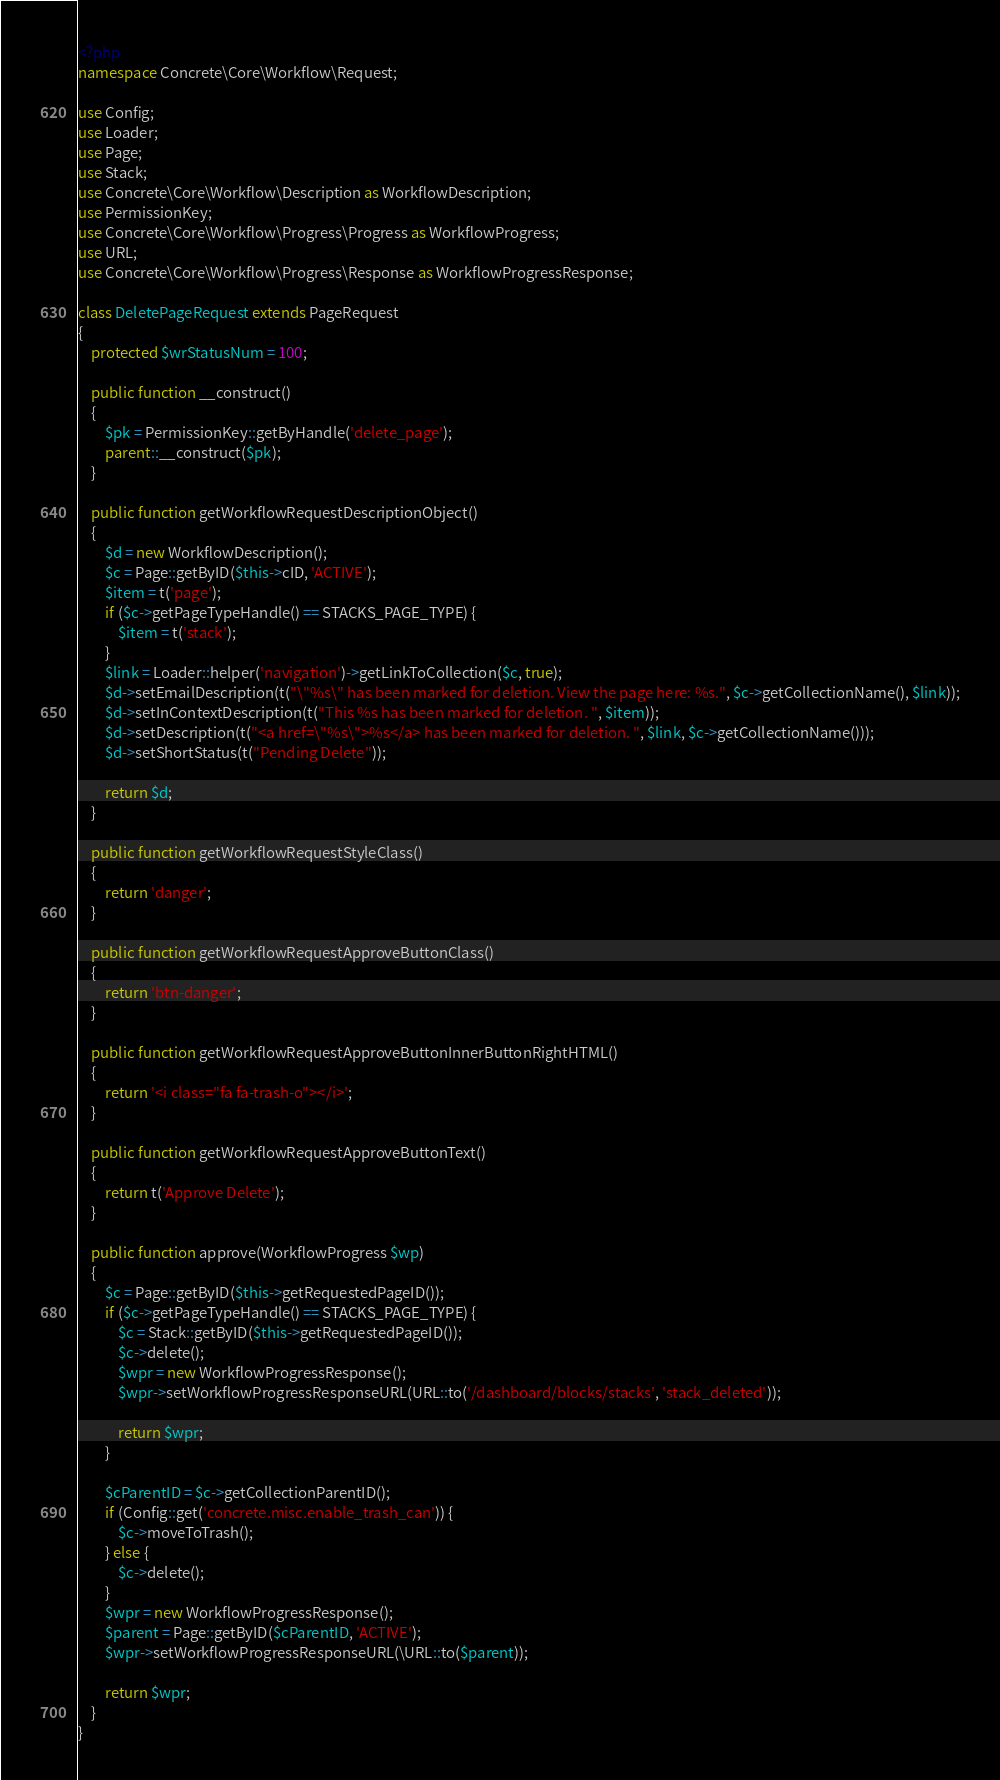<code> <loc_0><loc_0><loc_500><loc_500><_PHP_><?php
namespace Concrete\Core\Workflow\Request;

use Config;
use Loader;
use Page;
use Stack;
use Concrete\Core\Workflow\Description as WorkflowDescription;
use PermissionKey;
use Concrete\Core\Workflow\Progress\Progress as WorkflowProgress;
use URL;
use Concrete\Core\Workflow\Progress\Response as WorkflowProgressResponse;

class DeletePageRequest extends PageRequest
{
    protected $wrStatusNum = 100;

    public function __construct()
    {
        $pk = PermissionKey::getByHandle('delete_page');
        parent::__construct($pk);
    }

    public function getWorkflowRequestDescriptionObject()
    {
        $d = new WorkflowDescription();
        $c = Page::getByID($this->cID, 'ACTIVE');
        $item = t('page');
        if ($c->getPageTypeHandle() == STACKS_PAGE_TYPE) {
            $item = t('stack');
        }
        $link = Loader::helper('navigation')->getLinkToCollection($c, true);
        $d->setEmailDescription(t("\"%s\" has been marked for deletion. View the page here: %s.", $c->getCollectionName(), $link));
        $d->setInContextDescription(t("This %s has been marked for deletion. ", $item));
        $d->setDescription(t("<a href=\"%s\">%s</a> has been marked for deletion. ", $link, $c->getCollectionName()));
        $d->setShortStatus(t("Pending Delete"));

        return $d;
    }

    public function getWorkflowRequestStyleClass()
    {
        return 'danger';
    }

    public function getWorkflowRequestApproveButtonClass()
    {
        return 'btn-danger';
    }

    public function getWorkflowRequestApproveButtonInnerButtonRightHTML()
    {
        return '<i class="fa fa-trash-o"></i>';
    }

    public function getWorkflowRequestApproveButtonText()
    {
        return t('Approve Delete');
    }

    public function approve(WorkflowProgress $wp)
    {
        $c = Page::getByID($this->getRequestedPageID());
        if ($c->getPageTypeHandle() == STACKS_PAGE_TYPE) {
            $c = Stack::getByID($this->getRequestedPageID());
            $c->delete();
            $wpr = new WorkflowProgressResponse();
            $wpr->setWorkflowProgressResponseURL(URL::to('/dashboard/blocks/stacks', 'stack_deleted'));

            return $wpr;
        }

        $cParentID = $c->getCollectionParentID();
        if (Config::get('concrete.misc.enable_trash_can')) {
            $c->moveToTrash();
        } else {
            $c->delete();
        }
        $wpr = new WorkflowProgressResponse();
        $parent = Page::getByID($cParentID, 'ACTIVE');
        $wpr->setWorkflowProgressResponseURL(\URL::to($parent));

        return $wpr;
    }
}
</code> 